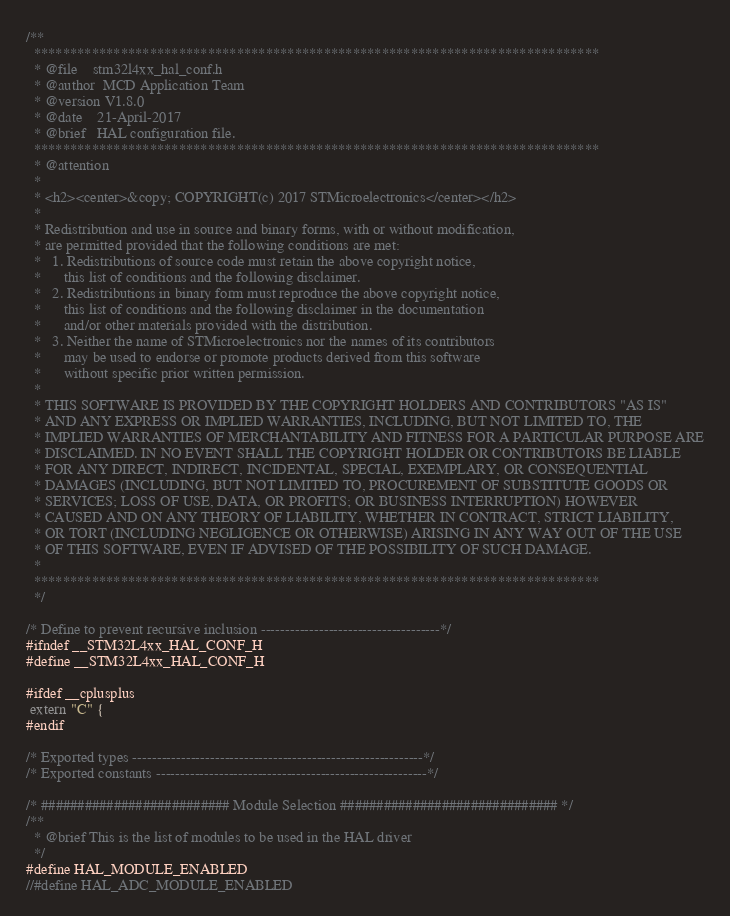<code> <loc_0><loc_0><loc_500><loc_500><_C_>/**
  ******************************************************************************
  * @file    stm32l4xx_hal_conf.h
  * @author  MCD Application Team
  * @version V1.8.0
  * @date    21-April-2017
  * @brief   HAL configuration file.
  ******************************************************************************
  * @attention
  *
  * <h2><center>&copy; COPYRIGHT(c) 2017 STMicroelectronics</center></h2>
  *
  * Redistribution and use in source and binary forms, with or without modification,
  * are permitted provided that the following conditions are met:
  *   1. Redistributions of source code must retain the above copyright notice,
  *      this list of conditions and the following disclaimer.
  *   2. Redistributions in binary form must reproduce the above copyright notice,
  *      this list of conditions and the following disclaimer in the documentation
  *      and/or other materials provided with the distribution.
  *   3. Neither the name of STMicroelectronics nor the names of its contributors
  *      may be used to endorse or promote products derived from this software
  *      without specific prior written permission.
  *
  * THIS SOFTWARE IS PROVIDED BY THE COPYRIGHT HOLDERS AND CONTRIBUTORS "AS IS"
  * AND ANY EXPRESS OR IMPLIED WARRANTIES, INCLUDING, BUT NOT LIMITED TO, THE
  * IMPLIED WARRANTIES OF MERCHANTABILITY AND FITNESS FOR A PARTICULAR PURPOSE ARE
  * DISCLAIMED. IN NO EVENT SHALL THE COPYRIGHT HOLDER OR CONTRIBUTORS BE LIABLE
  * FOR ANY DIRECT, INDIRECT, INCIDENTAL, SPECIAL, EXEMPLARY, OR CONSEQUENTIAL
  * DAMAGES (INCLUDING, BUT NOT LIMITED TO, PROCUREMENT OF SUBSTITUTE GOODS OR
  * SERVICES; LOSS OF USE, DATA, OR PROFITS; OR BUSINESS INTERRUPTION) HOWEVER
  * CAUSED AND ON ANY THEORY OF LIABILITY, WHETHER IN CONTRACT, STRICT LIABILITY,
  * OR TORT (INCLUDING NEGLIGENCE OR OTHERWISE) ARISING IN ANY WAY OUT OF THE USE
  * OF THIS SOFTWARE, EVEN IF ADVISED OF THE POSSIBILITY OF SUCH DAMAGE.
  *
  ******************************************************************************
  */

/* Define to prevent recursive inclusion -------------------------------------*/
#ifndef __STM32L4xx_HAL_CONF_H
#define __STM32L4xx_HAL_CONF_H

#ifdef __cplusplus
 extern "C" {
#endif

/* Exported types ------------------------------------------------------------*/
/* Exported constants --------------------------------------------------------*/

/* ########################## Module Selection ############################## */
/**
  * @brief This is the list of modules to be used in the HAL driver
  */
#define HAL_MODULE_ENABLED
//#define HAL_ADC_MODULE_ENABLED </code> 